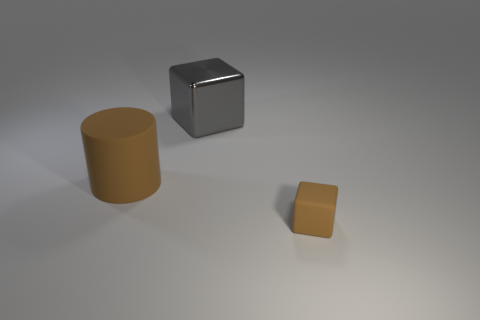What size is the rubber cylinder that is the same color as the small matte thing?
Your response must be concise. Large. What shape is the brown object that is to the right of the cube left of the rubber cube?
Offer a terse response. Cube. Are there any large cubes made of the same material as the gray thing?
Offer a terse response. No. What is the color of the other thing that is the same shape as the gray shiny thing?
Offer a very short reply. Brown. Are there fewer matte objects that are to the right of the gray cube than tiny brown blocks right of the tiny cube?
Offer a very short reply. No. What number of other objects are the same shape as the small matte object?
Your answer should be very brief. 1. Is the number of big cylinders in front of the rubber cylinder less than the number of big brown rubber objects?
Your answer should be very brief. Yes. There is a brown thing left of the small brown rubber cube; what is it made of?
Offer a very short reply. Rubber. What number of other things are the same size as the shiny cube?
Provide a succinct answer. 1. Is the number of green metal balls less than the number of big brown cylinders?
Your answer should be very brief. Yes. 